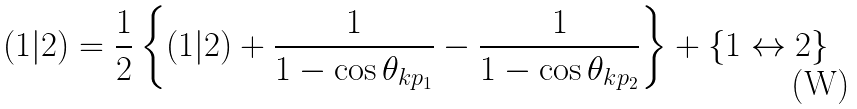Convert formula to latex. <formula><loc_0><loc_0><loc_500><loc_500>( 1 | 2 ) = \frac { 1 } { 2 } \left \{ ( 1 | 2 ) + \frac { 1 } { 1 - \cos \theta _ { k p _ { 1 } } } - \frac { 1 } { 1 - \cos \theta _ { k p _ { 2 } } } \right \} + \left \{ 1 \leftrightarrow 2 \right \}</formula> 